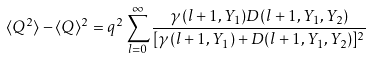<formula> <loc_0><loc_0><loc_500><loc_500>\langle Q ^ { 2 } \rangle - \langle Q \rangle ^ { 2 } = q ^ { 2 } \sum _ { l = 0 } ^ { \infty } \frac { \gamma ( l + 1 , Y _ { 1 } ) D ( l + 1 , Y _ { 1 } , Y _ { 2 } ) } { [ \gamma ( l + 1 , Y _ { 1 } ) + D ( l + 1 , Y _ { 1 } , Y _ { 2 } ) ] ^ { 2 } }</formula> 